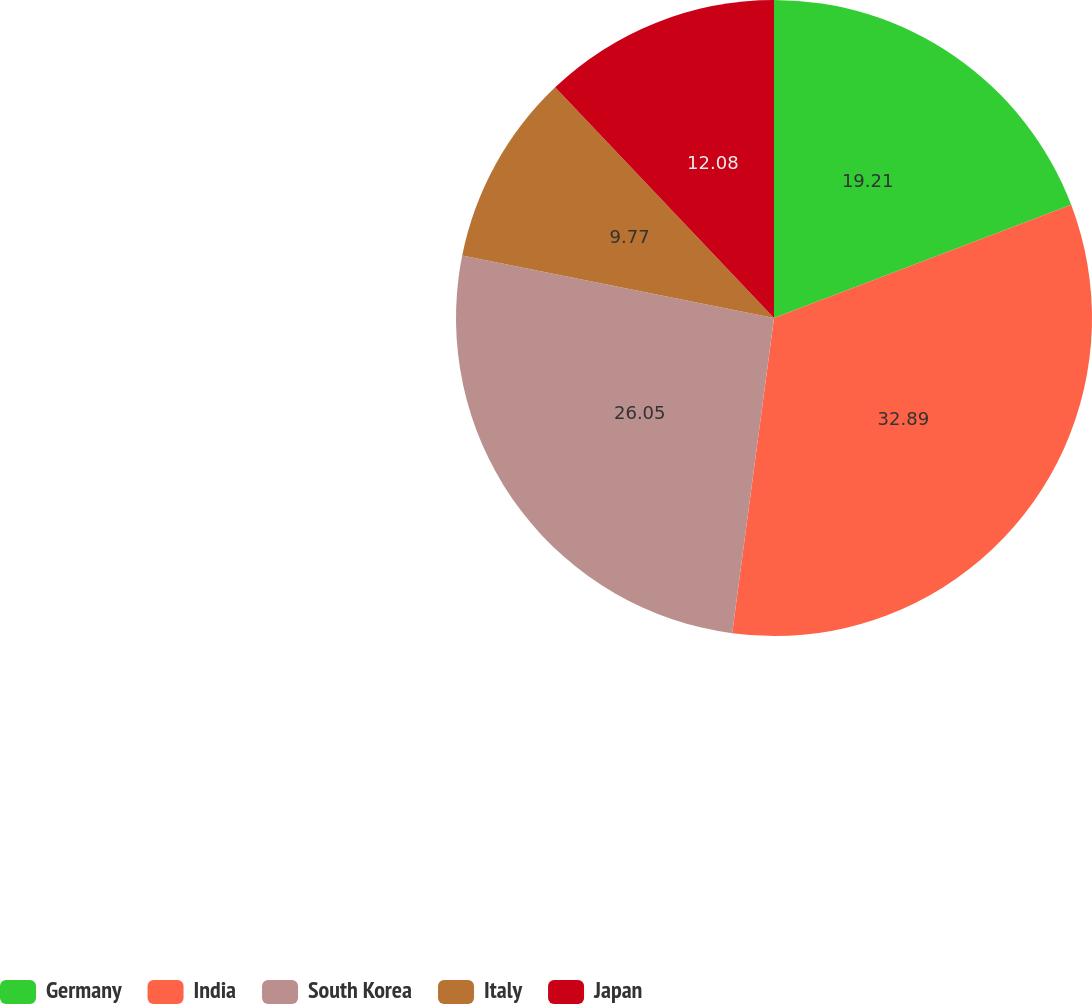Convert chart. <chart><loc_0><loc_0><loc_500><loc_500><pie_chart><fcel>Germany<fcel>India<fcel>South Korea<fcel>Italy<fcel>Japan<nl><fcel>19.21%<fcel>32.89%<fcel>26.05%<fcel>9.77%<fcel>12.08%<nl></chart> 